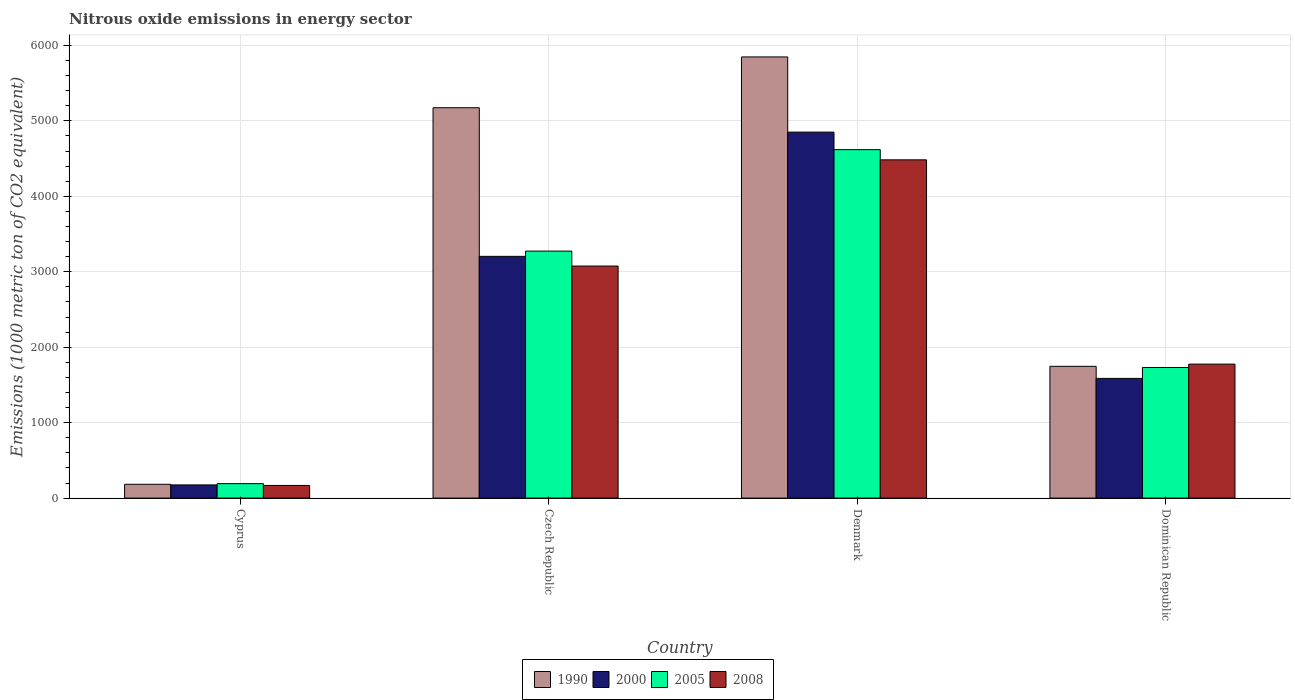How many different coloured bars are there?
Your answer should be very brief. 4. How many groups of bars are there?
Provide a succinct answer. 4. Are the number of bars per tick equal to the number of legend labels?
Give a very brief answer. Yes. Are the number of bars on each tick of the X-axis equal?
Provide a succinct answer. Yes. How many bars are there on the 2nd tick from the right?
Offer a terse response. 4. What is the label of the 1st group of bars from the left?
Give a very brief answer. Cyprus. What is the amount of nitrous oxide emitted in 2000 in Denmark?
Provide a succinct answer. 4850.8. Across all countries, what is the maximum amount of nitrous oxide emitted in 1990?
Offer a terse response. 5847.4. Across all countries, what is the minimum amount of nitrous oxide emitted in 2008?
Provide a short and direct response. 167.9. In which country was the amount of nitrous oxide emitted in 1990 maximum?
Give a very brief answer. Denmark. In which country was the amount of nitrous oxide emitted in 2005 minimum?
Your answer should be very brief. Cyprus. What is the total amount of nitrous oxide emitted in 2005 in the graph?
Provide a succinct answer. 9814.7. What is the difference between the amount of nitrous oxide emitted in 2008 in Czech Republic and that in Denmark?
Offer a terse response. -1407.8. What is the difference between the amount of nitrous oxide emitted in 2000 in Cyprus and the amount of nitrous oxide emitted in 2008 in Czech Republic?
Provide a succinct answer. -2901. What is the average amount of nitrous oxide emitted in 2000 per country?
Offer a very short reply. 2453.97. What is the difference between the amount of nitrous oxide emitted of/in 2000 and amount of nitrous oxide emitted of/in 2008 in Denmark?
Offer a very short reply. 367.4. In how many countries, is the amount of nitrous oxide emitted in 2008 greater than 5800 1000 metric ton?
Your answer should be very brief. 0. What is the ratio of the amount of nitrous oxide emitted in 2000 in Czech Republic to that in Dominican Republic?
Offer a very short reply. 2.02. Is the amount of nitrous oxide emitted in 1990 in Czech Republic less than that in Dominican Republic?
Ensure brevity in your answer.  No. Is the difference between the amount of nitrous oxide emitted in 2000 in Czech Republic and Dominican Republic greater than the difference between the amount of nitrous oxide emitted in 2008 in Czech Republic and Dominican Republic?
Provide a short and direct response. Yes. What is the difference between the highest and the second highest amount of nitrous oxide emitted in 2005?
Your response must be concise. -1344.9. What is the difference between the highest and the lowest amount of nitrous oxide emitted in 2008?
Your answer should be compact. 4315.5. In how many countries, is the amount of nitrous oxide emitted in 2000 greater than the average amount of nitrous oxide emitted in 2000 taken over all countries?
Your answer should be compact. 2. Is it the case that in every country, the sum of the amount of nitrous oxide emitted in 2000 and amount of nitrous oxide emitted in 1990 is greater than the sum of amount of nitrous oxide emitted in 2005 and amount of nitrous oxide emitted in 2008?
Offer a very short reply. No. What does the 4th bar from the right in Czech Republic represents?
Keep it short and to the point. 1990. Is it the case that in every country, the sum of the amount of nitrous oxide emitted in 1990 and amount of nitrous oxide emitted in 2005 is greater than the amount of nitrous oxide emitted in 2000?
Provide a succinct answer. Yes. How many bars are there?
Your response must be concise. 16. Are all the bars in the graph horizontal?
Offer a terse response. No. How many countries are there in the graph?
Your answer should be compact. 4. What is the difference between two consecutive major ticks on the Y-axis?
Offer a terse response. 1000. Are the values on the major ticks of Y-axis written in scientific E-notation?
Your answer should be very brief. No. Does the graph contain any zero values?
Offer a terse response. No. How are the legend labels stacked?
Your answer should be compact. Horizontal. What is the title of the graph?
Your response must be concise. Nitrous oxide emissions in energy sector. Does "2006" appear as one of the legend labels in the graph?
Offer a very short reply. No. What is the label or title of the Y-axis?
Offer a terse response. Emissions (1000 metric ton of CO2 equivalent). What is the Emissions (1000 metric ton of CO2 equivalent) in 1990 in Cyprus?
Your answer should be compact. 182.9. What is the Emissions (1000 metric ton of CO2 equivalent) of 2000 in Cyprus?
Your response must be concise. 174.6. What is the Emissions (1000 metric ton of CO2 equivalent) in 2005 in Cyprus?
Your answer should be compact. 191.4. What is the Emissions (1000 metric ton of CO2 equivalent) in 2008 in Cyprus?
Provide a succinct answer. 167.9. What is the Emissions (1000 metric ton of CO2 equivalent) of 1990 in Czech Republic?
Provide a succinct answer. 5174.1. What is the Emissions (1000 metric ton of CO2 equivalent) of 2000 in Czech Republic?
Offer a very short reply. 3204.1. What is the Emissions (1000 metric ton of CO2 equivalent) of 2005 in Czech Republic?
Your response must be concise. 3273.7. What is the Emissions (1000 metric ton of CO2 equivalent) in 2008 in Czech Republic?
Your response must be concise. 3075.6. What is the Emissions (1000 metric ton of CO2 equivalent) in 1990 in Denmark?
Ensure brevity in your answer.  5847.4. What is the Emissions (1000 metric ton of CO2 equivalent) of 2000 in Denmark?
Provide a short and direct response. 4850.8. What is the Emissions (1000 metric ton of CO2 equivalent) in 2005 in Denmark?
Make the answer very short. 4618.6. What is the Emissions (1000 metric ton of CO2 equivalent) in 2008 in Denmark?
Provide a short and direct response. 4483.4. What is the Emissions (1000 metric ton of CO2 equivalent) in 1990 in Dominican Republic?
Provide a short and direct response. 1746.5. What is the Emissions (1000 metric ton of CO2 equivalent) in 2000 in Dominican Republic?
Keep it short and to the point. 1586.4. What is the Emissions (1000 metric ton of CO2 equivalent) in 2005 in Dominican Republic?
Provide a short and direct response. 1731. What is the Emissions (1000 metric ton of CO2 equivalent) in 2008 in Dominican Republic?
Ensure brevity in your answer.  1775.7. Across all countries, what is the maximum Emissions (1000 metric ton of CO2 equivalent) of 1990?
Your response must be concise. 5847.4. Across all countries, what is the maximum Emissions (1000 metric ton of CO2 equivalent) in 2000?
Your response must be concise. 4850.8. Across all countries, what is the maximum Emissions (1000 metric ton of CO2 equivalent) in 2005?
Give a very brief answer. 4618.6. Across all countries, what is the maximum Emissions (1000 metric ton of CO2 equivalent) of 2008?
Provide a succinct answer. 4483.4. Across all countries, what is the minimum Emissions (1000 metric ton of CO2 equivalent) of 1990?
Ensure brevity in your answer.  182.9. Across all countries, what is the minimum Emissions (1000 metric ton of CO2 equivalent) in 2000?
Keep it short and to the point. 174.6. Across all countries, what is the minimum Emissions (1000 metric ton of CO2 equivalent) of 2005?
Your answer should be compact. 191.4. Across all countries, what is the minimum Emissions (1000 metric ton of CO2 equivalent) of 2008?
Your answer should be compact. 167.9. What is the total Emissions (1000 metric ton of CO2 equivalent) in 1990 in the graph?
Provide a short and direct response. 1.30e+04. What is the total Emissions (1000 metric ton of CO2 equivalent) of 2000 in the graph?
Offer a very short reply. 9815.9. What is the total Emissions (1000 metric ton of CO2 equivalent) of 2005 in the graph?
Give a very brief answer. 9814.7. What is the total Emissions (1000 metric ton of CO2 equivalent) of 2008 in the graph?
Keep it short and to the point. 9502.6. What is the difference between the Emissions (1000 metric ton of CO2 equivalent) in 1990 in Cyprus and that in Czech Republic?
Offer a terse response. -4991.2. What is the difference between the Emissions (1000 metric ton of CO2 equivalent) of 2000 in Cyprus and that in Czech Republic?
Your answer should be very brief. -3029.5. What is the difference between the Emissions (1000 metric ton of CO2 equivalent) of 2005 in Cyprus and that in Czech Republic?
Provide a short and direct response. -3082.3. What is the difference between the Emissions (1000 metric ton of CO2 equivalent) in 2008 in Cyprus and that in Czech Republic?
Make the answer very short. -2907.7. What is the difference between the Emissions (1000 metric ton of CO2 equivalent) in 1990 in Cyprus and that in Denmark?
Provide a short and direct response. -5664.5. What is the difference between the Emissions (1000 metric ton of CO2 equivalent) in 2000 in Cyprus and that in Denmark?
Your response must be concise. -4676.2. What is the difference between the Emissions (1000 metric ton of CO2 equivalent) in 2005 in Cyprus and that in Denmark?
Offer a terse response. -4427.2. What is the difference between the Emissions (1000 metric ton of CO2 equivalent) of 2008 in Cyprus and that in Denmark?
Keep it short and to the point. -4315.5. What is the difference between the Emissions (1000 metric ton of CO2 equivalent) of 1990 in Cyprus and that in Dominican Republic?
Make the answer very short. -1563.6. What is the difference between the Emissions (1000 metric ton of CO2 equivalent) of 2000 in Cyprus and that in Dominican Republic?
Ensure brevity in your answer.  -1411.8. What is the difference between the Emissions (1000 metric ton of CO2 equivalent) of 2005 in Cyprus and that in Dominican Republic?
Make the answer very short. -1539.6. What is the difference between the Emissions (1000 metric ton of CO2 equivalent) of 2008 in Cyprus and that in Dominican Republic?
Your response must be concise. -1607.8. What is the difference between the Emissions (1000 metric ton of CO2 equivalent) in 1990 in Czech Republic and that in Denmark?
Your answer should be very brief. -673.3. What is the difference between the Emissions (1000 metric ton of CO2 equivalent) in 2000 in Czech Republic and that in Denmark?
Keep it short and to the point. -1646.7. What is the difference between the Emissions (1000 metric ton of CO2 equivalent) of 2005 in Czech Republic and that in Denmark?
Offer a terse response. -1344.9. What is the difference between the Emissions (1000 metric ton of CO2 equivalent) in 2008 in Czech Republic and that in Denmark?
Provide a succinct answer. -1407.8. What is the difference between the Emissions (1000 metric ton of CO2 equivalent) in 1990 in Czech Republic and that in Dominican Republic?
Give a very brief answer. 3427.6. What is the difference between the Emissions (1000 metric ton of CO2 equivalent) in 2000 in Czech Republic and that in Dominican Republic?
Provide a short and direct response. 1617.7. What is the difference between the Emissions (1000 metric ton of CO2 equivalent) in 2005 in Czech Republic and that in Dominican Republic?
Ensure brevity in your answer.  1542.7. What is the difference between the Emissions (1000 metric ton of CO2 equivalent) in 2008 in Czech Republic and that in Dominican Republic?
Provide a succinct answer. 1299.9. What is the difference between the Emissions (1000 metric ton of CO2 equivalent) of 1990 in Denmark and that in Dominican Republic?
Ensure brevity in your answer.  4100.9. What is the difference between the Emissions (1000 metric ton of CO2 equivalent) of 2000 in Denmark and that in Dominican Republic?
Keep it short and to the point. 3264.4. What is the difference between the Emissions (1000 metric ton of CO2 equivalent) of 2005 in Denmark and that in Dominican Republic?
Your answer should be compact. 2887.6. What is the difference between the Emissions (1000 metric ton of CO2 equivalent) of 2008 in Denmark and that in Dominican Republic?
Your answer should be compact. 2707.7. What is the difference between the Emissions (1000 metric ton of CO2 equivalent) in 1990 in Cyprus and the Emissions (1000 metric ton of CO2 equivalent) in 2000 in Czech Republic?
Your answer should be compact. -3021.2. What is the difference between the Emissions (1000 metric ton of CO2 equivalent) in 1990 in Cyprus and the Emissions (1000 metric ton of CO2 equivalent) in 2005 in Czech Republic?
Offer a very short reply. -3090.8. What is the difference between the Emissions (1000 metric ton of CO2 equivalent) in 1990 in Cyprus and the Emissions (1000 metric ton of CO2 equivalent) in 2008 in Czech Republic?
Give a very brief answer. -2892.7. What is the difference between the Emissions (1000 metric ton of CO2 equivalent) of 2000 in Cyprus and the Emissions (1000 metric ton of CO2 equivalent) of 2005 in Czech Republic?
Offer a very short reply. -3099.1. What is the difference between the Emissions (1000 metric ton of CO2 equivalent) of 2000 in Cyprus and the Emissions (1000 metric ton of CO2 equivalent) of 2008 in Czech Republic?
Make the answer very short. -2901. What is the difference between the Emissions (1000 metric ton of CO2 equivalent) in 2005 in Cyprus and the Emissions (1000 metric ton of CO2 equivalent) in 2008 in Czech Republic?
Your answer should be very brief. -2884.2. What is the difference between the Emissions (1000 metric ton of CO2 equivalent) in 1990 in Cyprus and the Emissions (1000 metric ton of CO2 equivalent) in 2000 in Denmark?
Offer a very short reply. -4667.9. What is the difference between the Emissions (1000 metric ton of CO2 equivalent) in 1990 in Cyprus and the Emissions (1000 metric ton of CO2 equivalent) in 2005 in Denmark?
Provide a short and direct response. -4435.7. What is the difference between the Emissions (1000 metric ton of CO2 equivalent) in 1990 in Cyprus and the Emissions (1000 metric ton of CO2 equivalent) in 2008 in Denmark?
Give a very brief answer. -4300.5. What is the difference between the Emissions (1000 metric ton of CO2 equivalent) of 2000 in Cyprus and the Emissions (1000 metric ton of CO2 equivalent) of 2005 in Denmark?
Provide a short and direct response. -4444. What is the difference between the Emissions (1000 metric ton of CO2 equivalent) of 2000 in Cyprus and the Emissions (1000 metric ton of CO2 equivalent) of 2008 in Denmark?
Make the answer very short. -4308.8. What is the difference between the Emissions (1000 metric ton of CO2 equivalent) in 2005 in Cyprus and the Emissions (1000 metric ton of CO2 equivalent) in 2008 in Denmark?
Ensure brevity in your answer.  -4292. What is the difference between the Emissions (1000 metric ton of CO2 equivalent) of 1990 in Cyprus and the Emissions (1000 metric ton of CO2 equivalent) of 2000 in Dominican Republic?
Make the answer very short. -1403.5. What is the difference between the Emissions (1000 metric ton of CO2 equivalent) in 1990 in Cyprus and the Emissions (1000 metric ton of CO2 equivalent) in 2005 in Dominican Republic?
Provide a succinct answer. -1548.1. What is the difference between the Emissions (1000 metric ton of CO2 equivalent) in 1990 in Cyprus and the Emissions (1000 metric ton of CO2 equivalent) in 2008 in Dominican Republic?
Your answer should be compact. -1592.8. What is the difference between the Emissions (1000 metric ton of CO2 equivalent) of 2000 in Cyprus and the Emissions (1000 metric ton of CO2 equivalent) of 2005 in Dominican Republic?
Offer a very short reply. -1556.4. What is the difference between the Emissions (1000 metric ton of CO2 equivalent) in 2000 in Cyprus and the Emissions (1000 metric ton of CO2 equivalent) in 2008 in Dominican Republic?
Provide a succinct answer. -1601.1. What is the difference between the Emissions (1000 metric ton of CO2 equivalent) of 2005 in Cyprus and the Emissions (1000 metric ton of CO2 equivalent) of 2008 in Dominican Republic?
Your answer should be compact. -1584.3. What is the difference between the Emissions (1000 metric ton of CO2 equivalent) in 1990 in Czech Republic and the Emissions (1000 metric ton of CO2 equivalent) in 2000 in Denmark?
Your response must be concise. 323.3. What is the difference between the Emissions (1000 metric ton of CO2 equivalent) of 1990 in Czech Republic and the Emissions (1000 metric ton of CO2 equivalent) of 2005 in Denmark?
Your answer should be compact. 555.5. What is the difference between the Emissions (1000 metric ton of CO2 equivalent) of 1990 in Czech Republic and the Emissions (1000 metric ton of CO2 equivalent) of 2008 in Denmark?
Offer a very short reply. 690.7. What is the difference between the Emissions (1000 metric ton of CO2 equivalent) in 2000 in Czech Republic and the Emissions (1000 metric ton of CO2 equivalent) in 2005 in Denmark?
Ensure brevity in your answer.  -1414.5. What is the difference between the Emissions (1000 metric ton of CO2 equivalent) in 2000 in Czech Republic and the Emissions (1000 metric ton of CO2 equivalent) in 2008 in Denmark?
Provide a succinct answer. -1279.3. What is the difference between the Emissions (1000 metric ton of CO2 equivalent) in 2005 in Czech Republic and the Emissions (1000 metric ton of CO2 equivalent) in 2008 in Denmark?
Give a very brief answer. -1209.7. What is the difference between the Emissions (1000 metric ton of CO2 equivalent) in 1990 in Czech Republic and the Emissions (1000 metric ton of CO2 equivalent) in 2000 in Dominican Republic?
Provide a succinct answer. 3587.7. What is the difference between the Emissions (1000 metric ton of CO2 equivalent) of 1990 in Czech Republic and the Emissions (1000 metric ton of CO2 equivalent) of 2005 in Dominican Republic?
Keep it short and to the point. 3443.1. What is the difference between the Emissions (1000 metric ton of CO2 equivalent) in 1990 in Czech Republic and the Emissions (1000 metric ton of CO2 equivalent) in 2008 in Dominican Republic?
Your answer should be very brief. 3398.4. What is the difference between the Emissions (1000 metric ton of CO2 equivalent) in 2000 in Czech Republic and the Emissions (1000 metric ton of CO2 equivalent) in 2005 in Dominican Republic?
Your answer should be very brief. 1473.1. What is the difference between the Emissions (1000 metric ton of CO2 equivalent) of 2000 in Czech Republic and the Emissions (1000 metric ton of CO2 equivalent) of 2008 in Dominican Republic?
Provide a succinct answer. 1428.4. What is the difference between the Emissions (1000 metric ton of CO2 equivalent) in 2005 in Czech Republic and the Emissions (1000 metric ton of CO2 equivalent) in 2008 in Dominican Republic?
Offer a terse response. 1498. What is the difference between the Emissions (1000 metric ton of CO2 equivalent) of 1990 in Denmark and the Emissions (1000 metric ton of CO2 equivalent) of 2000 in Dominican Republic?
Make the answer very short. 4261. What is the difference between the Emissions (1000 metric ton of CO2 equivalent) of 1990 in Denmark and the Emissions (1000 metric ton of CO2 equivalent) of 2005 in Dominican Republic?
Provide a short and direct response. 4116.4. What is the difference between the Emissions (1000 metric ton of CO2 equivalent) in 1990 in Denmark and the Emissions (1000 metric ton of CO2 equivalent) in 2008 in Dominican Republic?
Your answer should be very brief. 4071.7. What is the difference between the Emissions (1000 metric ton of CO2 equivalent) in 2000 in Denmark and the Emissions (1000 metric ton of CO2 equivalent) in 2005 in Dominican Republic?
Your answer should be compact. 3119.8. What is the difference between the Emissions (1000 metric ton of CO2 equivalent) in 2000 in Denmark and the Emissions (1000 metric ton of CO2 equivalent) in 2008 in Dominican Republic?
Ensure brevity in your answer.  3075.1. What is the difference between the Emissions (1000 metric ton of CO2 equivalent) in 2005 in Denmark and the Emissions (1000 metric ton of CO2 equivalent) in 2008 in Dominican Republic?
Provide a short and direct response. 2842.9. What is the average Emissions (1000 metric ton of CO2 equivalent) in 1990 per country?
Provide a succinct answer. 3237.72. What is the average Emissions (1000 metric ton of CO2 equivalent) of 2000 per country?
Ensure brevity in your answer.  2453.97. What is the average Emissions (1000 metric ton of CO2 equivalent) in 2005 per country?
Keep it short and to the point. 2453.68. What is the average Emissions (1000 metric ton of CO2 equivalent) of 2008 per country?
Your answer should be compact. 2375.65. What is the difference between the Emissions (1000 metric ton of CO2 equivalent) in 1990 and Emissions (1000 metric ton of CO2 equivalent) in 2000 in Cyprus?
Keep it short and to the point. 8.3. What is the difference between the Emissions (1000 metric ton of CO2 equivalent) of 1990 and Emissions (1000 metric ton of CO2 equivalent) of 2005 in Cyprus?
Your response must be concise. -8.5. What is the difference between the Emissions (1000 metric ton of CO2 equivalent) in 1990 and Emissions (1000 metric ton of CO2 equivalent) in 2008 in Cyprus?
Your answer should be compact. 15. What is the difference between the Emissions (1000 metric ton of CO2 equivalent) in 2000 and Emissions (1000 metric ton of CO2 equivalent) in 2005 in Cyprus?
Give a very brief answer. -16.8. What is the difference between the Emissions (1000 metric ton of CO2 equivalent) in 2000 and Emissions (1000 metric ton of CO2 equivalent) in 2008 in Cyprus?
Offer a terse response. 6.7. What is the difference between the Emissions (1000 metric ton of CO2 equivalent) of 2005 and Emissions (1000 metric ton of CO2 equivalent) of 2008 in Cyprus?
Keep it short and to the point. 23.5. What is the difference between the Emissions (1000 metric ton of CO2 equivalent) of 1990 and Emissions (1000 metric ton of CO2 equivalent) of 2000 in Czech Republic?
Offer a terse response. 1970. What is the difference between the Emissions (1000 metric ton of CO2 equivalent) in 1990 and Emissions (1000 metric ton of CO2 equivalent) in 2005 in Czech Republic?
Keep it short and to the point. 1900.4. What is the difference between the Emissions (1000 metric ton of CO2 equivalent) in 1990 and Emissions (1000 metric ton of CO2 equivalent) in 2008 in Czech Republic?
Your answer should be very brief. 2098.5. What is the difference between the Emissions (1000 metric ton of CO2 equivalent) in 2000 and Emissions (1000 metric ton of CO2 equivalent) in 2005 in Czech Republic?
Give a very brief answer. -69.6. What is the difference between the Emissions (1000 metric ton of CO2 equivalent) of 2000 and Emissions (1000 metric ton of CO2 equivalent) of 2008 in Czech Republic?
Ensure brevity in your answer.  128.5. What is the difference between the Emissions (1000 metric ton of CO2 equivalent) in 2005 and Emissions (1000 metric ton of CO2 equivalent) in 2008 in Czech Republic?
Offer a terse response. 198.1. What is the difference between the Emissions (1000 metric ton of CO2 equivalent) in 1990 and Emissions (1000 metric ton of CO2 equivalent) in 2000 in Denmark?
Offer a terse response. 996.6. What is the difference between the Emissions (1000 metric ton of CO2 equivalent) of 1990 and Emissions (1000 metric ton of CO2 equivalent) of 2005 in Denmark?
Ensure brevity in your answer.  1228.8. What is the difference between the Emissions (1000 metric ton of CO2 equivalent) of 1990 and Emissions (1000 metric ton of CO2 equivalent) of 2008 in Denmark?
Make the answer very short. 1364. What is the difference between the Emissions (1000 metric ton of CO2 equivalent) of 2000 and Emissions (1000 metric ton of CO2 equivalent) of 2005 in Denmark?
Keep it short and to the point. 232.2. What is the difference between the Emissions (1000 metric ton of CO2 equivalent) in 2000 and Emissions (1000 metric ton of CO2 equivalent) in 2008 in Denmark?
Your answer should be very brief. 367.4. What is the difference between the Emissions (1000 metric ton of CO2 equivalent) in 2005 and Emissions (1000 metric ton of CO2 equivalent) in 2008 in Denmark?
Make the answer very short. 135.2. What is the difference between the Emissions (1000 metric ton of CO2 equivalent) in 1990 and Emissions (1000 metric ton of CO2 equivalent) in 2000 in Dominican Republic?
Your answer should be compact. 160.1. What is the difference between the Emissions (1000 metric ton of CO2 equivalent) of 1990 and Emissions (1000 metric ton of CO2 equivalent) of 2008 in Dominican Republic?
Your response must be concise. -29.2. What is the difference between the Emissions (1000 metric ton of CO2 equivalent) in 2000 and Emissions (1000 metric ton of CO2 equivalent) in 2005 in Dominican Republic?
Provide a succinct answer. -144.6. What is the difference between the Emissions (1000 metric ton of CO2 equivalent) of 2000 and Emissions (1000 metric ton of CO2 equivalent) of 2008 in Dominican Republic?
Provide a short and direct response. -189.3. What is the difference between the Emissions (1000 metric ton of CO2 equivalent) of 2005 and Emissions (1000 metric ton of CO2 equivalent) of 2008 in Dominican Republic?
Offer a very short reply. -44.7. What is the ratio of the Emissions (1000 metric ton of CO2 equivalent) of 1990 in Cyprus to that in Czech Republic?
Your response must be concise. 0.04. What is the ratio of the Emissions (1000 metric ton of CO2 equivalent) of 2000 in Cyprus to that in Czech Republic?
Your answer should be very brief. 0.05. What is the ratio of the Emissions (1000 metric ton of CO2 equivalent) of 2005 in Cyprus to that in Czech Republic?
Make the answer very short. 0.06. What is the ratio of the Emissions (1000 metric ton of CO2 equivalent) in 2008 in Cyprus to that in Czech Republic?
Your response must be concise. 0.05. What is the ratio of the Emissions (1000 metric ton of CO2 equivalent) of 1990 in Cyprus to that in Denmark?
Provide a short and direct response. 0.03. What is the ratio of the Emissions (1000 metric ton of CO2 equivalent) of 2000 in Cyprus to that in Denmark?
Keep it short and to the point. 0.04. What is the ratio of the Emissions (1000 metric ton of CO2 equivalent) in 2005 in Cyprus to that in Denmark?
Keep it short and to the point. 0.04. What is the ratio of the Emissions (1000 metric ton of CO2 equivalent) of 2008 in Cyprus to that in Denmark?
Ensure brevity in your answer.  0.04. What is the ratio of the Emissions (1000 metric ton of CO2 equivalent) of 1990 in Cyprus to that in Dominican Republic?
Your answer should be very brief. 0.1. What is the ratio of the Emissions (1000 metric ton of CO2 equivalent) in 2000 in Cyprus to that in Dominican Republic?
Keep it short and to the point. 0.11. What is the ratio of the Emissions (1000 metric ton of CO2 equivalent) of 2005 in Cyprus to that in Dominican Republic?
Provide a short and direct response. 0.11. What is the ratio of the Emissions (1000 metric ton of CO2 equivalent) in 2008 in Cyprus to that in Dominican Republic?
Provide a short and direct response. 0.09. What is the ratio of the Emissions (1000 metric ton of CO2 equivalent) of 1990 in Czech Republic to that in Denmark?
Provide a short and direct response. 0.88. What is the ratio of the Emissions (1000 metric ton of CO2 equivalent) of 2000 in Czech Republic to that in Denmark?
Offer a terse response. 0.66. What is the ratio of the Emissions (1000 metric ton of CO2 equivalent) of 2005 in Czech Republic to that in Denmark?
Offer a terse response. 0.71. What is the ratio of the Emissions (1000 metric ton of CO2 equivalent) in 2008 in Czech Republic to that in Denmark?
Keep it short and to the point. 0.69. What is the ratio of the Emissions (1000 metric ton of CO2 equivalent) in 1990 in Czech Republic to that in Dominican Republic?
Make the answer very short. 2.96. What is the ratio of the Emissions (1000 metric ton of CO2 equivalent) of 2000 in Czech Republic to that in Dominican Republic?
Give a very brief answer. 2.02. What is the ratio of the Emissions (1000 metric ton of CO2 equivalent) of 2005 in Czech Republic to that in Dominican Republic?
Provide a succinct answer. 1.89. What is the ratio of the Emissions (1000 metric ton of CO2 equivalent) in 2008 in Czech Republic to that in Dominican Republic?
Make the answer very short. 1.73. What is the ratio of the Emissions (1000 metric ton of CO2 equivalent) in 1990 in Denmark to that in Dominican Republic?
Give a very brief answer. 3.35. What is the ratio of the Emissions (1000 metric ton of CO2 equivalent) in 2000 in Denmark to that in Dominican Republic?
Your answer should be compact. 3.06. What is the ratio of the Emissions (1000 metric ton of CO2 equivalent) of 2005 in Denmark to that in Dominican Republic?
Your response must be concise. 2.67. What is the ratio of the Emissions (1000 metric ton of CO2 equivalent) of 2008 in Denmark to that in Dominican Republic?
Make the answer very short. 2.52. What is the difference between the highest and the second highest Emissions (1000 metric ton of CO2 equivalent) of 1990?
Provide a short and direct response. 673.3. What is the difference between the highest and the second highest Emissions (1000 metric ton of CO2 equivalent) in 2000?
Ensure brevity in your answer.  1646.7. What is the difference between the highest and the second highest Emissions (1000 metric ton of CO2 equivalent) in 2005?
Ensure brevity in your answer.  1344.9. What is the difference between the highest and the second highest Emissions (1000 metric ton of CO2 equivalent) of 2008?
Offer a terse response. 1407.8. What is the difference between the highest and the lowest Emissions (1000 metric ton of CO2 equivalent) in 1990?
Keep it short and to the point. 5664.5. What is the difference between the highest and the lowest Emissions (1000 metric ton of CO2 equivalent) in 2000?
Your response must be concise. 4676.2. What is the difference between the highest and the lowest Emissions (1000 metric ton of CO2 equivalent) in 2005?
Provide a succinct answer. 4427.2. What is the difference between the highest and the lowest Emissions (1000 metric ton of CO2 equivalent) in 2008?
Offer a very short reply. 4315.5. 